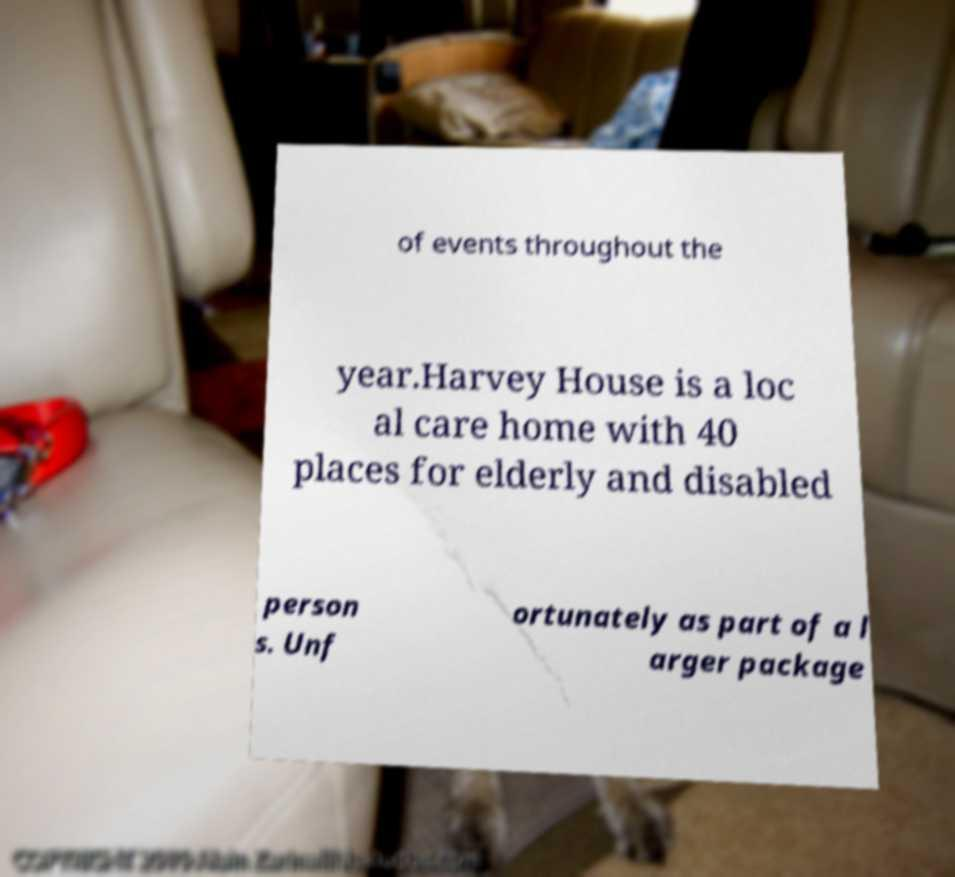I need the written content from this picture converted into text. Can you do that? of events throughout the year.Harvey House is a loc al care home with 40 places for elderly and disabled person s. Unf ortunately as part of a l arger package 